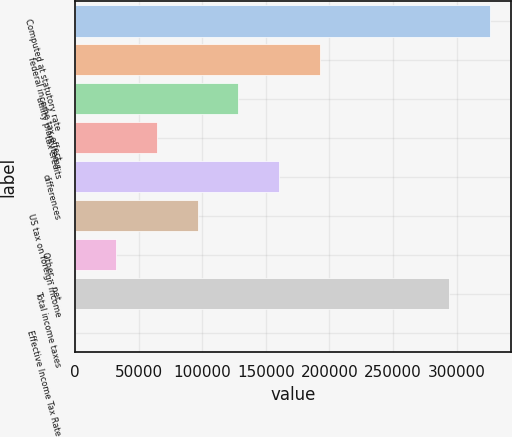Convert chart to OTSL. <chart><loc_0><loc_0><loc_500><loc_500><bar_chart><fcel>Computed at statutory rate<fcel>federal income tax effect<fcel>utility plant items<fcel>tax credits<fcel>differences<fcel>US tax on foreign income<fcel>Other -- net<fcel>Total income taxes<fcel>Effective Income Tax Rate<nl><fcel>326030<fcel>192585<fcel>128401<fcel>64216.5<fcel>160493<fcel>96308.7<fcel>32124.3<fcel>293938<fcel>32.1<nl></chart> 